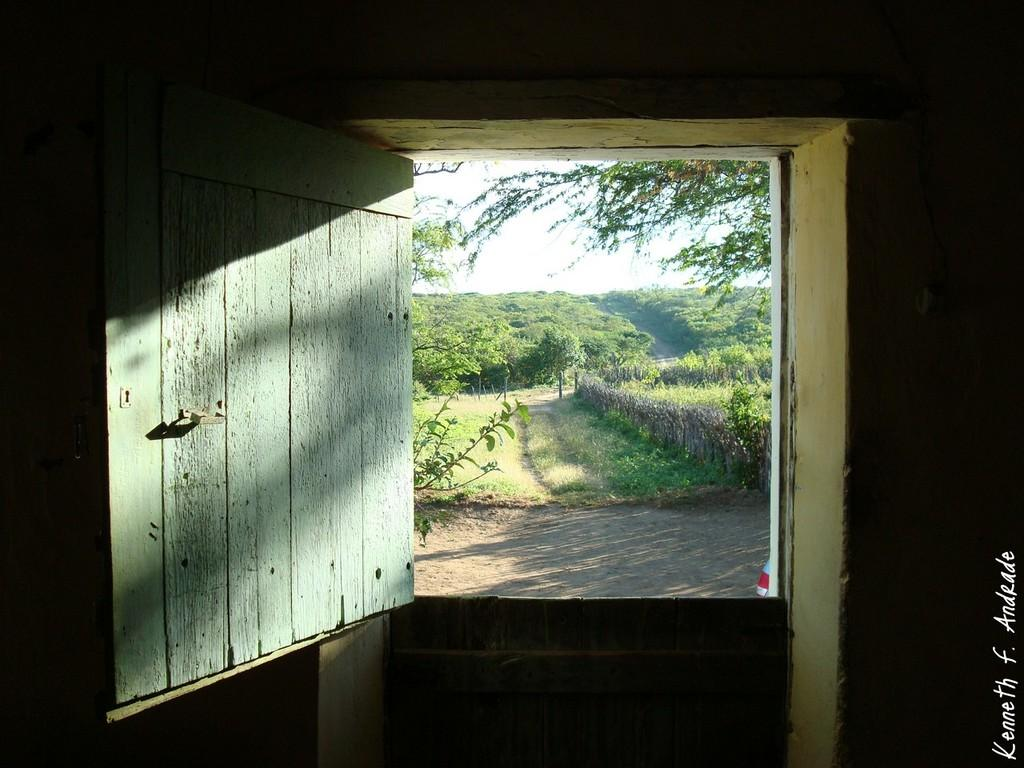What type of structures can be seen in the image? There are doors and a wall visible in the image. What type of vegetation is present in the image? There are plants, grass, and trees in the image. What part of the natural environment is visible in the image? The sky is visible in the image. What is the purpose of the watermark on the image? The watermark is likely for copyright or identification purposes. Can you describe the haircut of the tree in the image? There is no haircut to describe, as trees do not have hair. How fast do the plants run in the image? Plants do not run, as they are stationary and rooted in the ground. 